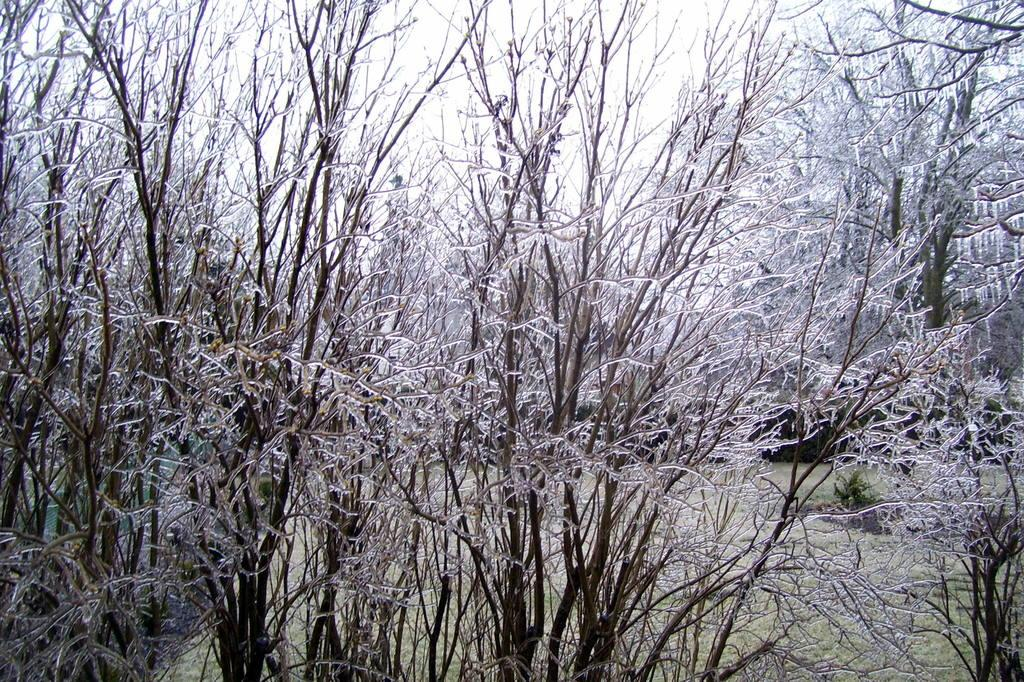Where was the picture taken? The picture was clicked outside. What can be seen in the foreground of the image? There are trees in the foreground of the image. What can be seen in the background of the image? There are plants and grass in the background of the image. What else is visible in the background of the image? The sky is visible in the background of the image. What type of muscle is being flexed by the judge in the image? There is no judge or muscle flexing present in the image. Can you tell me how many train tracks are visible in the image? There are no train tracks visible in the image. 